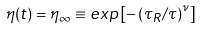Convert formula to latex. <formula><loc_0><loc_0><loc_500><loc_500>\eta ( t ) = \eta _ { \infty } \equiv e x p \left [ - \left ( \tau _ { R } / \tau \right ) ^ { \nu } \right ]</formula> 